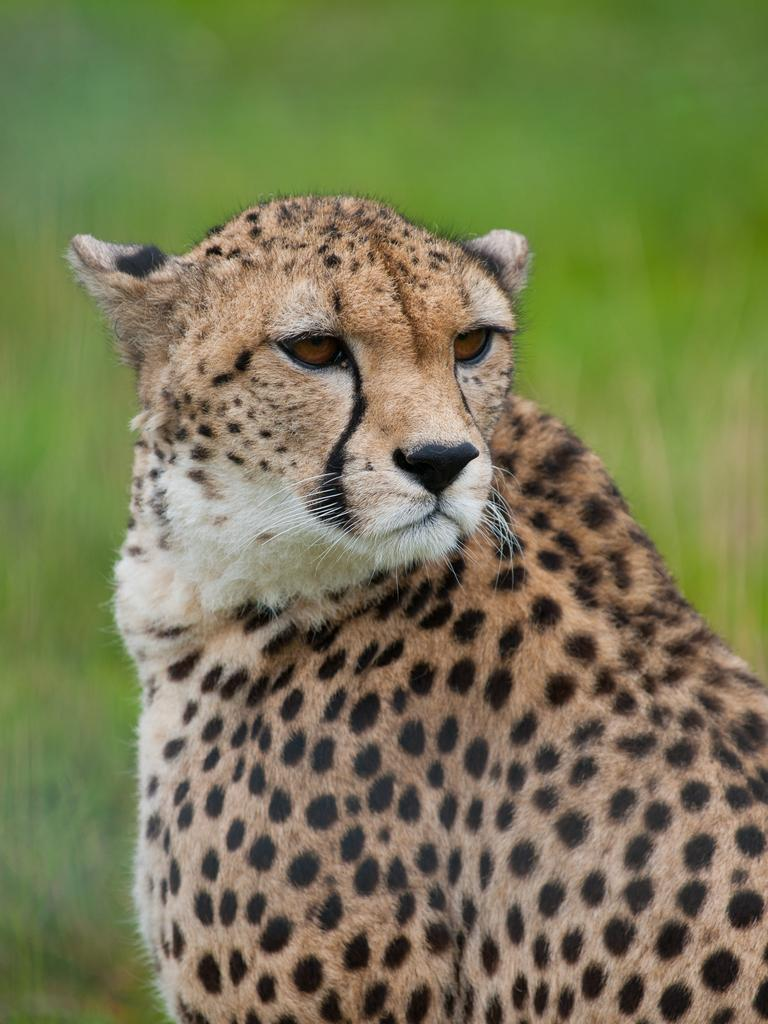What type of animal is in the image? There is a leopard in the image. What type of potato is being used to cry in the image? There is no potato or crying depicted in the image; it features a leopard. What type of blade is being used by the leopard in the image? There is no blade present in the image; it features a leopard without any tools or objects. 